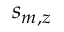Convert formula to latex. <formula><loc_0><loc_0><loc_500><loc_500>s _ { m , z }</formula> 